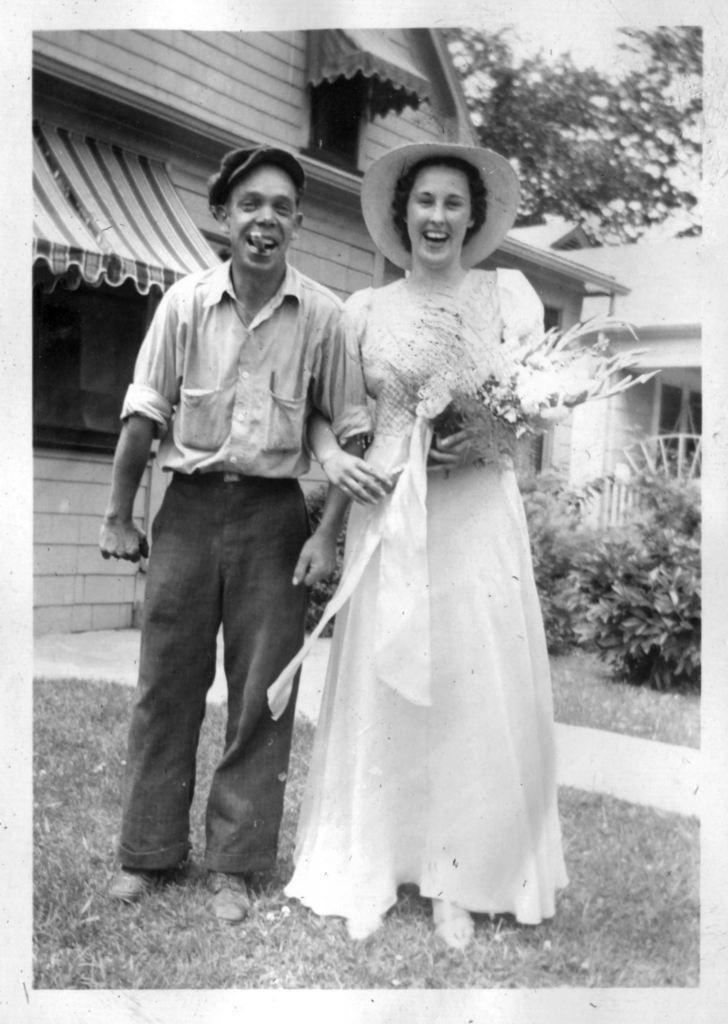What is the color scheme of the image? The image is black and white. How many people are in the image? There are two persons standing in the image. What is one person holding? One person is holding a bouquet. What structures can be seen in the image? There is a shop and a house in the image. What type of vegetation is present in the image? There are plants and trees in the image. Can you see any flames in the image? There are no flames present in the image. What type of pet can be seen in the image? There are no pets visible in the image. 